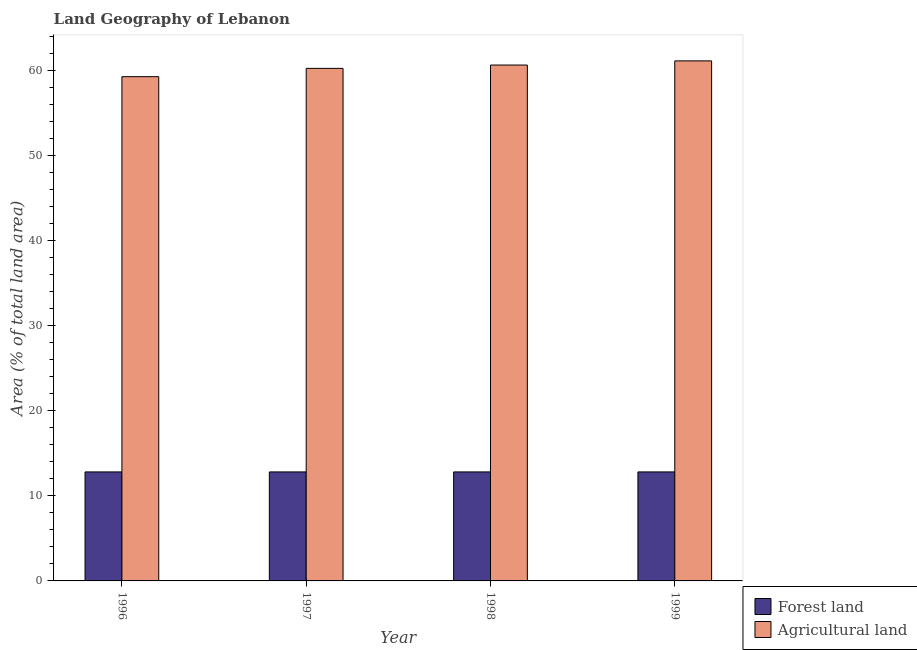How many different coloured bars are there?
Provide a short and direct response. 2. Are the number of bars per tick equal to the number of legend labels?
Your answer should be very brief. Yes. Are the number of bars on each tick of the X-axis equal?
Your answer should be compact. Yes. How many bars are there on the 4th tick from the left?
Your answer should be very brief. 2. What is the percentage of land area under forests in 1998?
Your answer should be very brief. 12.81. Across all years, what is the maximum percentage of land area under forests?
Ensure brevity in your answer.  12.81. Across all years, what is the minimum percentage of land area under agriculture?
Give a very brief answer. 59.24. What is the total percentage of land area under forests in the graph?
Your answer should be compact. 51.22. What is the average percentage of land area under agriculture per year?
Offer a terse response. 60.29. In the year 1998, what is the difference between the percentage of land area under forests and percentage of land area under agriculture?
Ensure brevity in your answer.  0. In how many years, is the percentage of land area under agriculture greater than 60 %?
Keep it short and to the point. 3. Is the percentage of land area under agriculture in 1996 less than that in 1998?
Ensure brevity in your answer.  Yes. Is the difference between the percentage of land area under forests in 1996 and 1999 greater than the difference between the percentage of land area under agriculture in 1996 and 1999?
Keep it short and to the point. No. What is the difference between the highest and the second highest percentage of land area under forests?
Give a very brief answer. 0. What is the difference between the highest and the lowest percentage of land area under agriculture?
Provide a short and direct response. 1.86. What does the 2nd bar from the left in 1997 represents?
Your answer should be compact. Agricultural land. What does the 1st bar from the right in 1998 represents?
Your response must be concise. Agricultural land. How many bars are there?
Your response must be concise. 8. What is the difference between two consecutive major ticks on the Y-axis?
Offer a very short reply. 10. Does the graph contain any zero values?
Make the answer very short. No. What is the title of the graph?
Offer a very short reply. Land Geography of Lebanon. What is the label or title of the Y-axis?
Your response must be concise. Area (% of total land area). What is the Area (% of total land area) in Forest land in 1996?
Ensure brevity in your answer.  12.81. What is the Area (% of total land area) of Agricultural land in 1996?
Your response must be concise. 59.24. What is the Area (% of total land area) in Forest land in 1997?
Offer a terse response. 12.81. What is the Area (% of total land area) of Agricultural land in 1997?
Ensure brevity in your answer.  60.22. What is the Area (% of total land area) in Forest land in 1998?
Provide a succinct answer. 12.81. What is the Area (% of total land area) in Agricultural land in 1998?
Provide a short and direct response. 60.61. What is the Area (% of total land area) in Forest land in 1999?
Offer a terse response. 12.81. What is the Area (% of total land area) in Agricultural land in 1999?
Ensure brevity in your answer.  61.09. Across all years, what is the maximum Area (% of total land area) in Forest land?
Keep it short and to the point. 12.81. Across all years, what is the maximum Area (% of total land area) in Agricultural land?
Your response must be concise. 61.09. Across all years, what is the minimum Area (% of total land area) in Forest land?
Ensure brevity in your answer.  12.81. Across all years, what is the minimum Area (% of total land area) of Agricultural land?
Your answer should be compact. 59.24. What is the total Area (% of total land area) in Forest land in the graph?
Make the answer very short. 51.22. What is the total Area (% of total land area) of Agricultural land in the graph?
Offer a very short reply. 241.15. What is the difference between the Area (% of total land area) of Agricultural land in 1996 and that in 1997?
Provide a succinct answer. -0.98. What is the difference between the Area (% of total land area) of Agricultural land in 1996 and that in 1998?
Keep it short and to the point. -1.37. What is the difference between the Area (% of total land area) of Forest land in 1996 and that in 1999?
Make the answer very short. 0. What is the difference between the Area (% of total land area) in Agricultural land in 1996 and that in 1999?
Provide a short and direct response. -1.86. What is the difference between the Area (% of total land area) of Agricultural land in 1997 and that in 1998?
Give a very brief answer. -0.39. What is the difference between the Area (% of total land area) of Agricultural land in 1997 and that in 1999?
Make the answer very short. -0.88. What is the difference between the Area (% of total land area) of Agricultural land in 1998 and that in 1999?
Give a very brief answer. -0.49. What is the difference between the Area (% of total land area) in Forest land in 1996 and the Area (% of total land area) in Agricultural land in 1997?
Ensure brevity in your answer.  -47.41. What is the difference between the Area (% of total land area) in Forest land in 1996 and the Area (% of total land area) in Agricultural land in 1998?
Offer a very short reply. -47.8. What is the difference between the Area (% of total land area) of Forest land in 1996 and the Area (% of total land area) of Agricultural land in 1999?
Your answer should be compact. -48.29. What is the difference between the Area (% of total land area) of Forest land in 1997 and the Area (% of total land area) of Agricultural land in 1998?
Ensure brevity in your answer.  -47.8. What is the difference between the Area (% of total land area) of Forest land in 1997 and the Area (% of total land area) of Agricultural land in 1999?
Provide a succinct answer. -48.29. What is the difference between the Area (% of total land area) of Forest land in 1998 and the Area (% of total land area) of Agricultural land in 1999?
Your response must be concise. -48.29. What is the average Area (% of total land area) in Forest land per year?
Provide a succinct answer. 12.81. What is the average Area (% of total land area) of Agricultural land per year?
Keep it short and to the point. 60.29. In the year 1996, what is the difference between the Area (% of total land area) of Forest land and Area (% of total land area) of Agricultural land?
Offer a very short reply. -46.43. In the year 1997, what is the difference between the Area (% of total land area) in Forest land and Area (% of total land area) in Agricultural land?
Offer a terse response. -47.41. In the year 1998, what is the difference between the Area (% of total land area) of Forest land and Area (% of total land area) of Agricultural land?
Provide a succinct answer. -47.8. In the year 1999, what is the difference between the Area (% of total land area) of Forest land and Area (% of total land area) of Agricultural land?
Keep it short and to the point. -48.29. What is the ratio of the Area (% of total land area) of Agricultural land in 1996 to that in 1997?
Provide a short and direct response. 0.98. What is the ratio of the Area (% of total land area) in Forest land in 1996 to that in 1998?
Offer a terse response. 1. What is the ratio of the Area (% of total land area) of Agricultural land in 1996 to that in 1998?
Ensure brevity in your answer.  0.98. What is the ratio of the Area (% of total land area) of Agricultural land in 1996 to that in 1999?
Your response must be concise. 0.97. What is the ratio of the Area (% of total land area) in Forest land in 1997 to that in 1999?
Your answer should be compact. 1. What is the ratio of the Area (% of total land area) of Agricultural land in 1997 to that in 1999?
Give a very brief answer. 0.99. What is the ratio of the Area (% of total land area) of Forest land in 1998 to that in 1999?
Ensure brevity in your answer.  1. What is the difference between the highest and the second highest Area (% of total land area) in Forest land?
Your answer should be very brief. 0. What is the difference between the highest and the second highest Area (% of total land area) in Agricultural land?
Your answer should be compact. 0.49. What is the difference between the highest and the lowest Area (% of total land area) in Forest land?
Ensure brevity in your answer.  0. What is the difference between the highest and the lowest Area (% of total land area) in Agricultural land?
Keep it short and to the point. 1.86. 